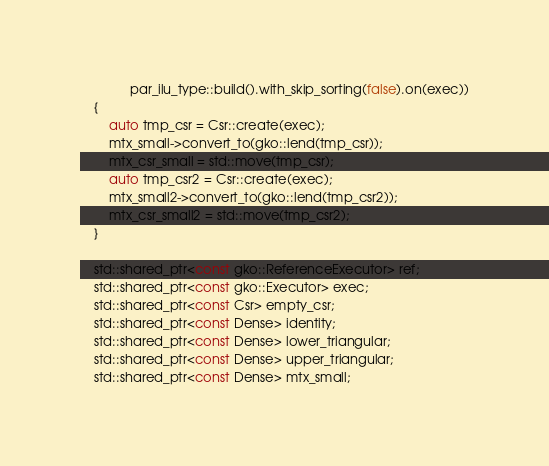<code> <loc_0><loc_0><loc_500><loc_500><_C++_>              par_ilu_type::build().with_skip_sorting(false).on(exec))
    {
        auto tmp_csr = Csr::create(exec);
        mtx_small->convert_to(gko::lend(tmp_csr));
        mtx_csr_small = std::move(tmp_csr);
        auto tmp_csr2 = Csr::create(exec);
        mtx_small2->convert_to(gko::lend(tmp_csr2));
        mtx_csr_small2 = std::move(tmp_csr2);
    }

    std::shared_ptr<const gko::ReferenceExecutor> ref;
    std::shared_ptr<const gko::Executor> exec;
    std::shared_ptr<const Csr> empty_csr;
    std::shared_ptr<const Dense> identity;
    std::shared_ptr<const Dense> lower_triangular;
    std::shared_ptr<const Dense> upper_triangular;
    std::shared_ptr<const Dense> mtx_small;</code> 